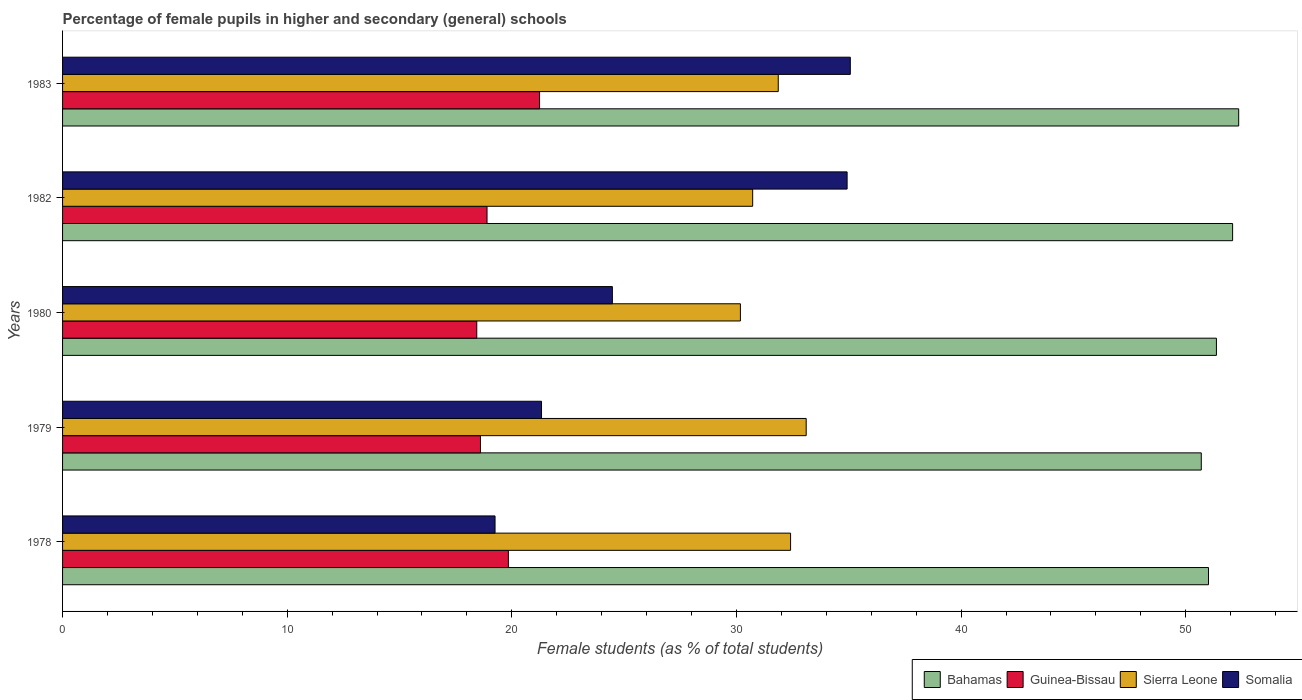How many different coloured bars are there?
Offer a terse response. 4. Are the number of bars per tick equal to the number of legend labels?
Your answer should be very brief. Yes. Are the number of bars on each tick of the Y-axis equal?
Your answer should be compact. Yes. How many bars are there on the 4th tick from the top?
Give a very brief answer. 4. How many bars are there on the 1st tick from the bottom?
Ensure brevity in your answer.  4. What is the label of the 1st group of bars from the top?
Provide a short and direct response. 1983. In how many cases, is the number of bars for a given year not equal to the number of legend labels?
Keep it short and to the point. 0. What is the percentage of female pupils in higher and secondary schools in Somalia in 1979?
Provide a succinct answer. 21.32. Across all years, what is the maximum percentage of female pupils in higher and secondary schools in Guinea-Bissau?
Provide a succinct answer. 21.23. Across all years, what is the minimum percentage of female pupils in higher and secondary schools in Guinea-Bissau?
Your response must be concise. 18.44. In which year was the percentage of female pupils in higher and secondary schools in Sierra Leone minimum?
Offer a very short reply. 1980. What is the total percentage of female pupils in higher and secondary schools in Sierra Leone in the graph?
Your response must be concise. 158.27. What is the difference between the percentage of female pupils in higher and secondary schools in Sierra Leone in 1980 and that in 1982?
Your answer should be compact. -0.55. What is the difference between the percentage of female pupils in higher and secondary schools in Somalia in 1979 and the percentage of female pupils in higher and secondary schools in Guinea-Bissau in 1983?
Your answer should be compact. 0.09. What is the average percentage of female pupils in higher and secondary schools in Sierra Leone per year?
Ensure brevity in your answer.  31.65. In the year 1982, what is the difference between the percentage of female pupils in higher and secondary schools in Guinea-Bissau and percentage of female pupils in higher and secondary schools in Somalia?
Your answer should be very brief. -16.03. What is the ratio of the percentage of female pupils in higher and secondary schools in Sierra Leone in 1979 to that in 1980?
Make the answer very short. 1.1. Is the difference between the percentage of female pupils in higher and secondary schools in Guinea-Bissau in 1979 and 1980 greater than the difference between the percentage of female pupils in higher and secondary schools in Somalia in 1979 and 1980?
Make the answer very short. Yes. What is the difference between the highest and the second highest percentage of female pupils in higher and secondary schools in Bahamas?
Your answer should be very brief. 0.27. What is the difference between the highest and the lowest percentage of female pupils in higher and secondary schools in Sierra Leone?
Offer a terse response. 2.93. What does the 1st bar from the top in 1978 represents?
Make the answer very short. Somalia. What does the 1st bar from the bottom in 1983 represents?
Ensure brevity in your answer.  Bahamas. How many years are there in the graph?
Keep it short and to the point. 5. Does the graph contain grids?
Give a very brief answer. No. What is the title of the graph?
Provide a short and direct response. Percentage of female pupils in higher and secondary (general) schools. Does "Switzerland" appear as one of the legend labels in the graph?
Your answer should be very brief. No. What is the label or title of the X-axis?
Make the answer very short. Female students (as % of total students). What is the label or title of the Y-axis?
Provide a short and direct response. Years. What is the Female students (as % of total students) of Bahamas in 1978?
Give a very brief answer. 51.01. What is the Female students (as % of total students) in Guinea-Bissau in 1978?
Give a very brief answer. 19.85. What is the Female students (as % of total students) in Sierra Leone in 1978?
Ensure brevity in your answer.  32.41. What is the Female students (as % of total students) in Somalia in 1978?
Your response must be concise. 19.25. What is the Female students (as % of total students) in Bahamas in 1979?
Provide a succinct answer. 50.69. What is the Female students (as % of total students) in Guinea-Bissau in 1979?
Make the answer very short. 18.6. What is the Female students (as % of total students) in Sierra Leone in 1979?
Make the answer very short. 33.1. What is the Female students (as % of total students) in Somalia in 1979?
Ensure brevity in your answer.  21.32. What is the Female students (as % of total students) of Bahamas in 1980?
Your answer should be compact. 51.37. What is the Female students (as % of total students) in Guinea-Bissau in 1980?
Keep it short and to the point. 18.44. What is the Female students (as % of total students) in Sierra Leone in 1980?
Ensure brevity in your answer.  30.17. What is the Female students (as % of total students) of Somalia in 1980?
Make the answer very short. 24.48. What is the Female students (as % of total students) of Bahamas in 1982?
Your answer should be very brief. 52.09. What is the Female students (as % of total students) of Guinea-Bissau in 1982?
Ensure brevity in your answer.  18.9. What is the Female students (as % of total students) of Sierra Leone in 1982?
Offer a very short reply. 30.72. What is the Female students (as % of total students) of Somalia in 1982?
Give a very brief answer. 34.92. What is the Female students (as % of total students) in Bahamas in 1983?
Ensure brevity in your answer.  52.36. What is the Female students (as % of total students) in Guinea-Bissau in 1983?
Provide a succinct answer. 21.23. What is the Female students (as % of total students) of Sierra Leone in 1983?
Give a very brief answer. 31.86. What is the Female students (as % of total students) in Somalia in 1983?
Give a very brief answer. 35.07. Across all years, what is the maximum Female students (as % of total students) of Bahamas?
Your response must be concise. 52.36. Across all years, what is the maximum Female students (as % of total students) of Guinea-Bissau?
Keep it short and to the point. 21.23. Across all years, what is the maximum Female students (as % of total students) of Sierra Leone?
Provide a short and direct response. 33.1. Across all years, what is the maximum Female students (as % of total students) of Somalia?
Keep it short and to the point. 35.07. Across all years, what is the minimum Female students (as % of total students) of Bahamas?
Provide a short and direct response. 50.69. Across all years, what is the minimum Female students (as % of total students) of Guinea-Bissau?
Your answer should be very brief. 18.44. Across all years, what is the minimum Female students (as % of total students) in Sierra Leone?
Give a very brief answer. 30.17. Across all years, what is the minimum Female students (as % of total students) of Somalia?
Make the answer very short. 19.25. What is the total Female students (as % of total students) in Bahamas in the graph?
Offer a terse response. 257.51. What is the total Female students (as % of total students) in Guinea-Bissau in the graph?
Your answer should be compact. 97.02. What is the total Female students (as % of total students) in Sierra Leone in the graph?
Your answer should be compact. 158.27. What is the total Female students (as % of total students) of Somalia in the graph?
Your response must be concise. 135.04. What is the difference between the Female students (as % of total students) of Bahamas in 1978 and that in 1979?
Your response must be concise. 0.32. What is the difference between the Female students (as % of total students) in Guinea-Bissau in 1978 and that in 1979?
Your answer should be compact. 1.24. What is the difference between the Female students (as % of total students) of Sierra Leone in 1978 and that in 1979?
Give a very brief answer. -0.7. What is the difference between the Female students (as % of total students) of Somalia in 1978 and that in 1979?
Give a very brief answer. -2.07. What is the difference between the Female students (as % of total students) in Bahamas in 1978 and that in 1980?
Offer a very short reply. -0.35. What is the difference between the Female students (as % of total students) of Guinea-Bissau in 1978 and that in 1980?
Your response must be concise. 1.41. What is the difference between the Female students (as % of total students) in Sierra Leone in 1978 and that in 1980?
Provide a short and direct response. 2.23. What is the difference between the Female students (as % of total students) of Somalia in 1978 and that in 1980?
Make the answer very short. -5.22. What is the difference between the Female students (as % of total students) in Bahamas in 1978 and that in 1982?
Provide a short and direct response. -1.07. What is the difference between the Female students (as % of total students) of Guinea-Bissau in 1978 and that in 1982?
Your answer should be very brief. 0.95. What is the difference between the Female students (as % of total students) in Sierra Leone in 1978 and that in 1982?
Give a very brief answer. 1.69. What is the difference between the Female students (as % of total students) of Somalia in 1978 and that in 1982?
Make the answer very short. -15.67. What is the difference between the Female students (as % of total students) of Bahamas in 1978 and that in 1983?
Your response must be concise. -1.34. What is the difference between the Female students (as % of total students) of Guinea-Bissau in 1978 and that in 1983?
Your response must be concise. -1.39. What is the difference between the Female students (as % of total students) in Sierra Leone in 1978 and that in 1983?
Give a very brief answer. 0.55. What is the difference between the Female students (as % of total students) in Somalia in 1978 and that in 1983?
Offer a very short reply. -15.82. What is the difference between the Female students (as % of total students) of Bahamas in 1979 and that in 1980?
Make the answer very short. -0.67. What is the difference between the Female students (as % of total students) of Guinea-Bissau in 1979 and that in 1980?
Your answer should be very brief. 0.17. What is the difference between the Female students (as % of total students) of Sierra Leone in 1979 and that in 1980?
Keep it short and to the point. 2.93. What is the difference between the Female students (as % of total students) in Somalia in 1979 and that in 1980?
Provide a short and direct response. -3.15. What is the difference between the Female students (as % of total students) in Bahamas in 1979 and that in 1982?
Provide a short and direct response. -1.39. What is the difference between the Female students (as % of total students) in Guinea-Bissau in 1979 and that in 1982?
Offer a very short reply. -0.29. What is the difference between the Female students (as % of total students) of Sierra Leone in 1979 and that in 1982?
Ensure brevity in your answer.  2.38. What is the difference between the Female students (as % of total students) in Somalia in 1979 and that in 1982?
Your response must be concise. -13.6. What is the difference between the Female students (as % of total students) in Bahamas in 1979 and that in 1983?
Offer a very short reply. -1.67. What is the difference between the Female students (as % of total students) in Guinea-Bissau in 1979 and that in 1983?
Your response must be concise. -2.63. What is the difference between the Female students (as % of total students) in Sierra Leone in 1979 and that in 1983?
Make the answer very short. 1.24. What is the difference between the Female students (as % of total students) of Somalia in 1979 and that in 1983?
Your answer should be compact. -13.75. What is the difference between the Female students (as % of total students) in Bahamas in 1980 and that in 1982?
Provide a succinct answer. -0.72. What is the difference between the Female students (as % of total students) of Guinea-Bissau in 1980 and that in 1982?
Make the answer very short. -0.46. What is the difference between the Female students (as % of total students) in Sierra Leone in 1980 and that in 1982?
Your answer should be compact. -0.55. What is the difference between the Female students (as % of total students) in Somalia in 1980 and that in 1982?
Your response must be concise. -10.45. What is the difference between the Female students (as % of total students) in Bahamas in 1980 and that in 1983?
Provide a succinct answer. -0.99. What is the difference between the Female students (as % of total students) in Guinea-Bissau in 1980 and that in 1983?
Ensure brevity in your answer.  -2.8. What is the difference between the Female students (as % of total students) in Sierra Leone in 1980 and that in 1983?
Your answer should be very brief. -1.68. What is the difference between the Female students (as % of total students) of Somalia in 1980 and that in 1983?
Provide a short and direct response. -10.59. What is the difference between the Female students (as % of total students) of Bahamas in 1982 and that in 1983?
Provide a succinct answer. -0.27. What is the difference between the Female students (as % of total students) in Guinea-Bissau in 1982 and that in 1983?
Make the answer very short. -2.34. What is the difference between the Female students (as % of total students) in Sierra Leone in 1982 and that in 1983?
Your answer should be compact. -1.14. What is the difference between the Female students (as % of total students) in Somalia in 1982 and that in 1983?
Your response must be concise. -0.14. What is the difference between the Female students (as % of total students) in Bahamas in 1978 and the Female students (as % of total students) in Guinea-Bissau in 1979?
Make the answer very short. 32.41. What is the difference between the Female students (as % of total students) in Bahamas in 1978 and the Female students (as % of total students) in Sierra Leone in 1979?
Keep it short and to the point. 17.91. What is the difference between the Female students (as % of total students) in Bahamas in 1978 and the Female students (as % of total students) in Somalia in 1979?
Give a very brief answer. 29.69. What is the difference between the Female students (as % of total students) of Guinea-Bissau in 1978 and the Female students (as % of total students) of Sierra Leone in 1979?
Your answer should be very brief. -13.26. What is the difference between the Female students (as % of total students) of Guinea-Bissau in 1978 and the Female students (as % of total students) of Somalia in 1979?
Provide a short and direct response. -1.48. What is the difference between the Female students (as % of total students) of Sierra Leone in 1978 and the Female students (as % of total students) of Somalia in 1979?
Offer a very short reply. 11.09. What is the difference between the Female students (as % of total students) in Bahamas in 1978 and the Female students (as % of total students) in Guinea-Bissau in 1980?
Your answer should be very brief. 32.57. What is the difference between the Female students (as % of total students) in Bahamas in 1978 and the Female students (as % of total students) in Sierra Leone in 1980?
Your answer should be compact. 20.84. What is the difference between the Female students (as % of total students) in Bahamas in 1978 and the Female students (as % of total students) in Somalia in 1980?
Offer a very short reply. 26.54. What is the difference between the Female students (as % of total students) of Guinea-Bissau in 1978 and the Female students (as % of total students) of Sierra Leone in 1980?
Give a very brief answer. -10.33. What is the difference between the Female students (as % of total students) in Guinea-Bissau in 1978 and the Female students (as % of total students) in Somalia in 1980?
Provide a short and direct response. -4.63. What is the difference between the Female students (as % of total students) in Sierra Leone in 1978 and the Female students (as % of total students) in Somalia in 1980?
Provide a short and direct response. 7.93. What is the difference between the Female students (as % of total students) of Bahamas in 1978 and the Female students (as % of total students) of Guinea-Bissau in 1982?
Give a very brief answer. 32.12. What is the difference between the Female students (as % of total students) of Bahamas in 1978 and the Female students (as % of total students) of Sierra Leone in 1982?
Provide a succinct answer. 20.29. What is the difference between the Female students (as % of total students) in Bahamas in 1978 and the Female students (as % of total students) in Somalia in 1982?
Provide a succinct answer. 16.09. What is the difference between the Female students (as % of total students) in Guinea-Bissau in 1978 and the Female students (as % of total students) in Sierra Leone in 1982?
Your answer should be compact. -10.88. What is the difference between the Female students (as % of total students) of Guinea-Bissau in 1978 and the Female students (as % of total students) of Somalia in 1982?
Provide a succinct answer. -15.08. What is the difference between the Female students (as % of total students) in Sierra Leone in 1978 and the Female students (as % of total students) in Somalia in 1982?
Offer a terse response. -2.52. What is the difference between the Female students (as % of total students) of Bahamas in 1978 and the Female students (as % of total students) of Guinea-Bissau in 1983?
Provide a short and direct response. 29.78. What is the difference between the Female students (as % of total students) in Bahamas in 1978 and the Female students (as % of total students) in Sierra Leone in 1983?
Ensure brevity in your answer.  19.15. What is the difference between the Female students (as % of total students) in Bahamas in 1978 and the Female students (as % of total students) in Somalia in 1983?
Offer a terse response. 15.94. What is the difference between the Female students (as % of total students) in Guinea-Bissau in 1978 and the Female students (as % of total students) in Sierra Leone in 1983?
Keep it short and to the point. -12.01. What is the difference between the Female students (as % of total students) of Guinea-Bissau in 1978 and the Female students (as % of total students) of Somalia in 1983?
Your answer should be compact. -15.22. What is the difference between the Female students (as % of total students) of Sierra Leone in 1978 and the Female students (as % of total students) of Somalia in 1983?
Provide a succinct answer. -2.66. What is the difference between the Female students (as % of total students) in Bahamas in 1979 and the Female students (as % of total students) in Guinea-Bissau in 1980?
Offer a terse response. 32.25. What is the difference between the Female students (as % of total students) in Bahamas in 1979 and the Female students (as % of total students) in Sierra Leone in 1980?
Your answer should be compact. 20.52. What is the difference between the Female students (as % of total students) of Bahamas in 1979 and the Female students (as % of total students) of Somalia in 1980?
Your response must be concise. 26.22. What is the difference between the Female students (as % of total students) in Guinea-Bissau in 1979 and the Female students (as % of total students) in Sierra Leone in 1980?
Offer a terse response. -11.57. What is the difference between the Female students (as % of total students) in Guinea-Bissau in 1979 and the Female students (as % of total students) in Somalia in 1980?
Keep it short and to the point. -5.87. What is the difference between the Female students (as % of total students) in Sierra Leone in 1979 and the Female students (as % of total students) in Somalia in 1980?
Ensure brevity in your answer.  8.63. What is the difference between the Female students (as % of total students) of Bahamas in 1979 and the Female students (as % of total students) of Guinea-Bissau in 1982?
Keep it short and to the point. 31.8. What is the difference between the Female students (as % of total students) of Bahamas in 1979 and the Female students (as % of total students) of Sierra Leone in 1982?
Offer a very short reply. 19.97. What is the difference between the Female students (as % of total students) in Bahamas in 1979 and the Female students (as % of total students) in Somalia in 1982?
Keep it short and to the point. 15.77. What is the difference between the Female students (as % of total students) in Guinea-Bissau in 1979 and the Female students (as % of total students) in Sierra Leone in 1982?
Provide a short and direct response. -12.12. What is the difference between the Female students (as % of total students) in Guinea-Bissau in 1979 and the Female students (as % of total students) in Somalia in 1982?
Provide a short and direct response. -16.32. What is the difference between the Female students (as % of total students) of Sierra Leone in 1979 and the Female students (as % of total students) of Somalia in 1982?
Offer a terse response. -1.82. What is the difference between the Female students (as % of total students) of Bahamas in 1979 and the Female students (as % of total students) of Guinea-Bissau in 1983?
Keep it short and to the point. 29.46. What is the difference between the Female students (as % of total students) in Bahamas in 1979 and the Female students (as % of total students) in Sierra Leone in 1983?
Provide a short and direct response. 18.83. What is the difference between the Female students (as % of total students) in Bahamas in 1979 and the Female students (as % of total students) in Somalia in 1983?
Make the answer very short. 15.62. What is the difference between the Female students (as % of total students) in Guinea-Bissau in 1979 and the Female students (as % of total students) in Sierra Leone in 1983?
Your response must be concise. -13.26. What is the difference between the Female students (as % of total students) in Guinea-Bissau in 1979 and the Female students (as % of total students) in Somalia in 1983?
Give a very brief answer. -16.46. What is the difference between the Female students (as % of total students) in Sierra Leone in 1979 and the Female students (as % of total students) in Somalia in 1983?
Offer a very short reply. -1.96. What is the difference between the Female students (as % of total students) in Bahamas in 1980 and the Female students (as % of total students) in Guinea-Bissau in 1982?
Ensure brevity in your answer.  32.47. What is the difference between the Female students (as % of total students) in Bahamas in 1980 and the Female students (as % of total students) in Sierra Leone in 1982?
Make the answer very short. 20.64. What is the difference between the Female students (as % of total students) of Bahamas in 1980 and the Female students (as % of total students) of Somalia in 1982?
Your response must be concise. 16.44. What is the difference between the Female students (as % of total students) in Guinea-Bissau in 1980 and the Female students (as % of total students) in Sierra Leone in 1982?
Your response must be concise. -12.28. What is the difference between the Female students (as % of total students) of Guinea-Bissau in 1980 and the Female students (as % of total students) of Somalia in 1982?
Make the answer very short. -16.49. What is the difference between the Female students (as % of total students) in Sierra Leone in 1980 and the Female students (as % of total students) in Somalia in 1982?
Keep it short and to the point. -4.75. What is the difference between the Female students (as % of total students) in Bahamas in 1980 and the Female students (as % of total students) in Guinea-Bissau in 1983?
Offer a very short reply. 30.13. What is the difference between the Female students (as % of total students) of Bahamas in 1980 and the Female students (as % of total students) of Sierra Leone in 1983?
Your answer should be compact. 19.51. What is the difference between the Female students (as % of total students) of Bahamas in 1980 and the Female students (as % of total students) of Somalia in 1983?
Your response must be concise. 16.3. What is the difference between the Female students (as % of total students) of Guinea-Bissau in 1980 and the Female students (as % of total students) of Sierra Leone in 1983?
Make the answer very short. -13.42. What is the difference between the Female students (as % of total students) in Guinea-Bissau in 1980 and the Female students (as % of total students) in Somalia in 1983?
Provide a succinct answer. -16.63. What is the difference between the Female students (as % of total students) in Sierra Leone in 1980 and the Female students (as % of total students) in Somalia in 1983?
Give a very brief answer. -4.89. What is the difference between the Female students (as % of total students) of Bahamas in 1982 and the Female students (as % of total students) of Guinea-Bissau in 1983?
Provide a succinct answer. 30.85. What is the difference between the Female students (as % of total students) in Bahamas in 1982 and the Female students (as % of total students) in Sierra Leone in 1983?
Your answer should be very brief. 20.23. What is the difference between the Female students (as % of total students) of Bahamas in 1982 and the Female students (as % of total students) of Somalia in 1983?
Provide a succinct answer. 17.02. What is the difference between the Female students (as % of total students) of Guinea-Bissau in 1982 and the Female students (as % of total students) of Sierra Leone in 1983?
Give a very brief answer. -12.96. What is the difference between the Female students (as % of total students) in Guinea-Bissau in 1982 and the Female students (as % of total students) in Somalia in 1983?
Keep it short and to the point. -16.17. What is the difference between the Female students (as % of total students) of Sierra Leone in 1982 and the Female students (as % of total students) of Somalia in 1983?
Offer a terse response. -4.35. What is the average Female students (as % of total students) of Bahamas per year?
Make the answer very short. 51.5. What is the average Female students (as % of total students) of Guinea-Bissau per year?
Offer a terse response. 19.4. What is the average Female students (as % of total students) in Sierra Leone per year?
Keep it short and to the point. 31.65. What is the average Female students (as % of total students) of Somalia per year?
Offer a terse response. 27.01. In the year 1978, what is the difference between the Female students (as % of total students) of Bahamas and Female students (as % of total students) of Guinea-Bissau?
Your response must be concise. 31.17. In the year 1978, what is the difference between the Female students (as % of total students) of Bahamas and Female students (as % of total students) of Sierra Leone?
Provide a short and direct response. 18.6. In the year 1978, what is the difference between the Female students (as % of total students) in Bahamas and Female students (as % of total students) in Somalia?
Offer a terse response. 31.76. In the year 1978, what is the difference between the Female students (as % of total students) of Guinea-Bissau and Female students (as % of total students) of Sierra Leone?
Offer a very short reply. -12.56. In the year 1978, what is the difference between the Female students (as % of total students) in Guinea-Bissau and Female students (as % of total students) in Somalia?
Ensure brevity in your answer.  0.59. In the year 1978, what is the difference between the Female students (as % of total students) of Sierra Leone and Female students (as % of total students) of Somalia?
Your answer should be very brief. 13.16. In the year 1979, what is the difference between the Female students (as % of total students) of Bahamas and Female students (as % of total students) of Guinea-Bissau?
Keep it short and to the point. 32.09. In the year 1979, what is the difference between the Female students (as % of total students) in Bahamas and Female students (as % of total students) in Sierra Leone?
Offer a terse response. 17.59. In the year 1979, what is the difference between the Female students (as % of total students) of Bahamas and Female students (as % of total students) of Somalia?
Keep it short and to the point. 29.37. In the year 1979, what is the difference between the Female students (as % of total students) in Guinea-Bissau and Female students (as % of total students) in Somalia?
Give a very brief answer. -2.72. In the year 1979, what is the difference between the Female students (as % of total students) of Sierra Leone and Female students (as % of total students) of Somalia?
Keep it short and to the point. 11.78. In the year 1980, what is the difference between the Female students (as % of total students) in Bahamas and Female students (as % of total students) in Guinea-Bissau?
Offer a terse response. 32.93. In the year 1980, what is the difference between the Female students (as % of total students) in Bahamas and Female students (as % of total students) in Sierra Leone?
Make the answer very short. 21.19. In the year 1980, what is the difference between the Female students (as % of total students) of Bahamas and Female students (as % of total students) of Somalia?
Make the answer very short. 26.89. In the year 1980, what is the difference between the Female students (as % of total students) of Guinea-Bissau and Female students (as % of total students) of Sierra Leone?
Offer a very short reply. -11.74. In the year 1980, what is the difference between the Female students (as % of total students) of Guinea-Bissau and Female students (as % of total students) of Somalia?
Ensure brevity in your answer.  -6.04. In the year 1980, what is the difference between the Female students (as % of total students) of Sierra Leone and Female students (as % of total students) of Somalia?
Your answer should be very brief. 5.7. In the year 1982, what is the difference between the Female students (as % of total students) in Bahamas and Female students (as % of total students) in Guinea-Bissau?
Your answer should be compact. 33.19. In the year 1982, what is the difference between the Female students (as % of total students) in Bahamas and Female students (as % of total students) in Sierra Leone?
Provide a succinct answer. 21.36. In the year 1982, what is the difference between the Female students (as % of total students) in Bahamas and Female students (as % of total students) in Somalia?
Your response must be concise. 17.16. In the year 1982, what is the difference between the Female students (as % of total students) in Guinea-Bissau and Female students (as % of total students) in Sierra Leone?
Your response must be concise. -11.83. In the year 1982, what is the difference between the Female students (as % of total students) in Guinea-Bissau and Female students (as % of total students) in Somalia?
Your answer should be compact. -16.03. In the year 1982, what is the difference between the Female students (as % of total students) in Sierra Leone and Female students (as % of total students) in Somalia?
Keep it short and to the point. -4.2. In the year 1983, what is the difference between the Female students (as % of total students) in Bahamas and Female students (as % of total students) in Guinea-Bissau?
Make the answer very short. 31.12. In the year 1983, what is the difference between the Female students (as % of total students) in Bahamas and Female students (as % of total students) in Sierra Leone?
Ensure brevity in your answer.  20.5. In the year 1983, what is the difference between the Female students (as % of total students) of Bahamas and Female students (as % of total students) of Somalia?
Offer a very short reply. 17.29. In the year 1983, what is the difference between the Female students (as % of total students) in Guinea-Bissau and Female students (as % of total students) in Sierra Leone?
Offer a very short reply. -10.63. In the year 1983, what is the difference between the Female students (as % of total students) of Guinea-Bissau and Female students (as % of total students) of Somalia?
Offer a very short reply. -13.83. In the year 1983, what is the difference between the Female students (as % of total students) in Sierra Leone and Female students (as % of total students) in Somalia?
Provide a short and direct response. -3.21. What is the ratio of the Female students (as % of total students) of Bahamas in 1978 to that in 1979?
Make the answer very short. 1.01. What is the ratio of the Female students (as % of total students) of Guinea-Bissau in 1978 to that in 1979?
Keep it short and to the point. 1.07. What is the ratio of the Female students (as % of total students) of Somalia in 1978 to that in 1979?
Ensure brevity in your answer.  0.9. What is the ratio of the Female students (as % of total students) of Bahamas in 1978 to that in 1980?
Offer a very short reply. 0.99. What is the ratio of the Female students (as % of total students) of Guinea-Bissau in 1978 to that in 1980?
Offer a terse response. 1.08. What is the ratio of the Female students (as % of total students) in Sierra Leone in 1978 to that in 1980?
Offer a terse response. 1.07. What is the ratio of the Female students (as % of total students) in Somalia in 1978 to that in 1980?
Offer a terse response. 0.79. What is the ratio of the Female students (as % of total students) in Bahamas in 1978 to that in 1982?
Make the answer very short. 0.98. What is the ratio of the Female students (as % of total students) of Guinea-Bissau in 1978 to that in 1982?
Provide a short and direct response. 1.05. What is the ratio of the Female students (as % of total students) of Sierra Leone in 1978 to that in 1982?
Provide a succinct answer. 1.05. What is the ratio of the Female students (as % of total students) in Somalia in 1978 to that in 1982?
Offer a very short reply. 0.55. What is the ratio of the Female students (as % of total students) in Bahamas in 1978 to that in 1983?
Your response must be concise. 0.97. What is the ratio of the Female students (as % of total students) in Guinea-Bissau in 1978 to that in 1983?
Offer a very short reply. 0.93. What is the ratio of the Female students (as % of total students) in Sierra Leone in 1978 to that in 1983?
Ensure brevity in your answer.  1.02. What is the ratio of the Female students (as % of total students) in Somalia in 1978 to that in 1983?
Your answer should be compact. 0.55. What is the ratio of the Female students (as % of total students) in Bahamas in 1979 to that in 1980?
Provide a short and direct response. 0.99. What is the ratio of the Female students (as % of total students) of Guinea-Bissau in 1979 to that in 1980?
Offer a terse response. 1.01. What is the ratio of the Female students (as % of total students) of Sierra Leone in 1979 to that in 1980?
Provide a short and direct response. 1.1. What is the ratio of the Female students (as % of total students) of Somalia in 1979 to that in 1980?
Give a very brief answer. 0.87. What is the ratio of the Female students (as % of total students) of Bahamas in 1979 to that in 1982?
Your answer should be compact. 0.97. What is the ratio of the Female students (as % of total students) of Guinea-Bissau in 1979 to that in 1982?
Ensure brevity in your answer.  0.98. What is the ratio of the Female students (as % of total students) of Sierra Leone in 1979 to that in 1982?
Offer a very short reply. 1.08. What is the ratio of the Female students (as % of total students) of Somalia in 1979 to that in 1982?
Provide a succinct answer. 0.61. What is the ratio of the Female students (as % of total students) of Bahamas in 1979 to that in 1983?
Ensure brevity in your answer.  0.97. What is the ratio of the Female students (as % of total students) of Guinea-Bissau in 1979 to that in 1983?
Your answer should be very brief. 0.88. What is the ratio of the Female students (as % of total students) of Sierra Leone in 1979 to that in 1983?
Offer a very short reply. 1.04. What is the ratio of the Female students (as % of total students) in Somalia in 1979 to that in 1983?
Provide a short and direct response. 0.61. What is the ratio of the Female students (as % of total students) of Bahamas in 1980 to that in 1982?
Make the answer very short. 0.99. What is the ratio of the Female students (as % of total students) of Guinea-Bissau in 1980 to that in 1982?
Keep it short and to the point. 0.98. What is the ratio of the Female students (as % of total students) of Sierra Leone in 1980 to that in 1982?
Ensure brevity in your answer.  0.98. What is the ratio of the Female students (as % of total students) of Somalia in 1980 to that in 1982?
Your response must be concise. 0.7. What is the ratio of the Female students (as % of total students) in Bahamas in 1980 to that in 1983?
Your answer should be compact. 0.98. What is the ratio of the Female students (as % of total students) of Guinea-Bissau in 1980 to that in 1983?
Ensure brevity in your answer.  0.87. What is the ratio of the Female students (as % of total students) of Sierra Leone in 1980 to that in 1983?
Your answer should be compact. 0.95. What is the ratio of the Female students (as % of total students) in Somalia in 1980 to that in 1983?
Your answer should be compact. 0.7. What is the ratio of the Female students (as % of total students) in Guinea-Bissau in 1982 to that in 1983?
Provide a short and direct response. 0.89. What is the difference between the highest and the second highest Female students (as % of total students) in Bahamas?
Your response must be concise. 0.27. What is the difference between the highest and the second highest Female students (as % of total students) of Guinea-Bissau?
Your answer should be very brief. 1.39. What is the difference between the highest and the second highest Female students (as % of total students) in Sierra Leone?
Provide a succinct answer. 0.7. What is the difference between the highest and the second highest Female students (as % of total students) in Somalia?
Your answer should be compact. 0.14. What is the difference between the highest and the lowest Female students (as % of total students) in Bahamas?
Provide a succinct answer. 1.67. What is the difference between the highest and the lowest Female students (as % of total students) in Guinea-Bissau?
Make the answer very short. 2.8. What is the difference between the highest and the lowest Female students (as % of total students) of Sierra Leone?
Your response must be concise. 2.93. What is the difference between the highest and the lowest Female students (as % of total students) of Somalia?
Offer a very short reply. 15.82. 